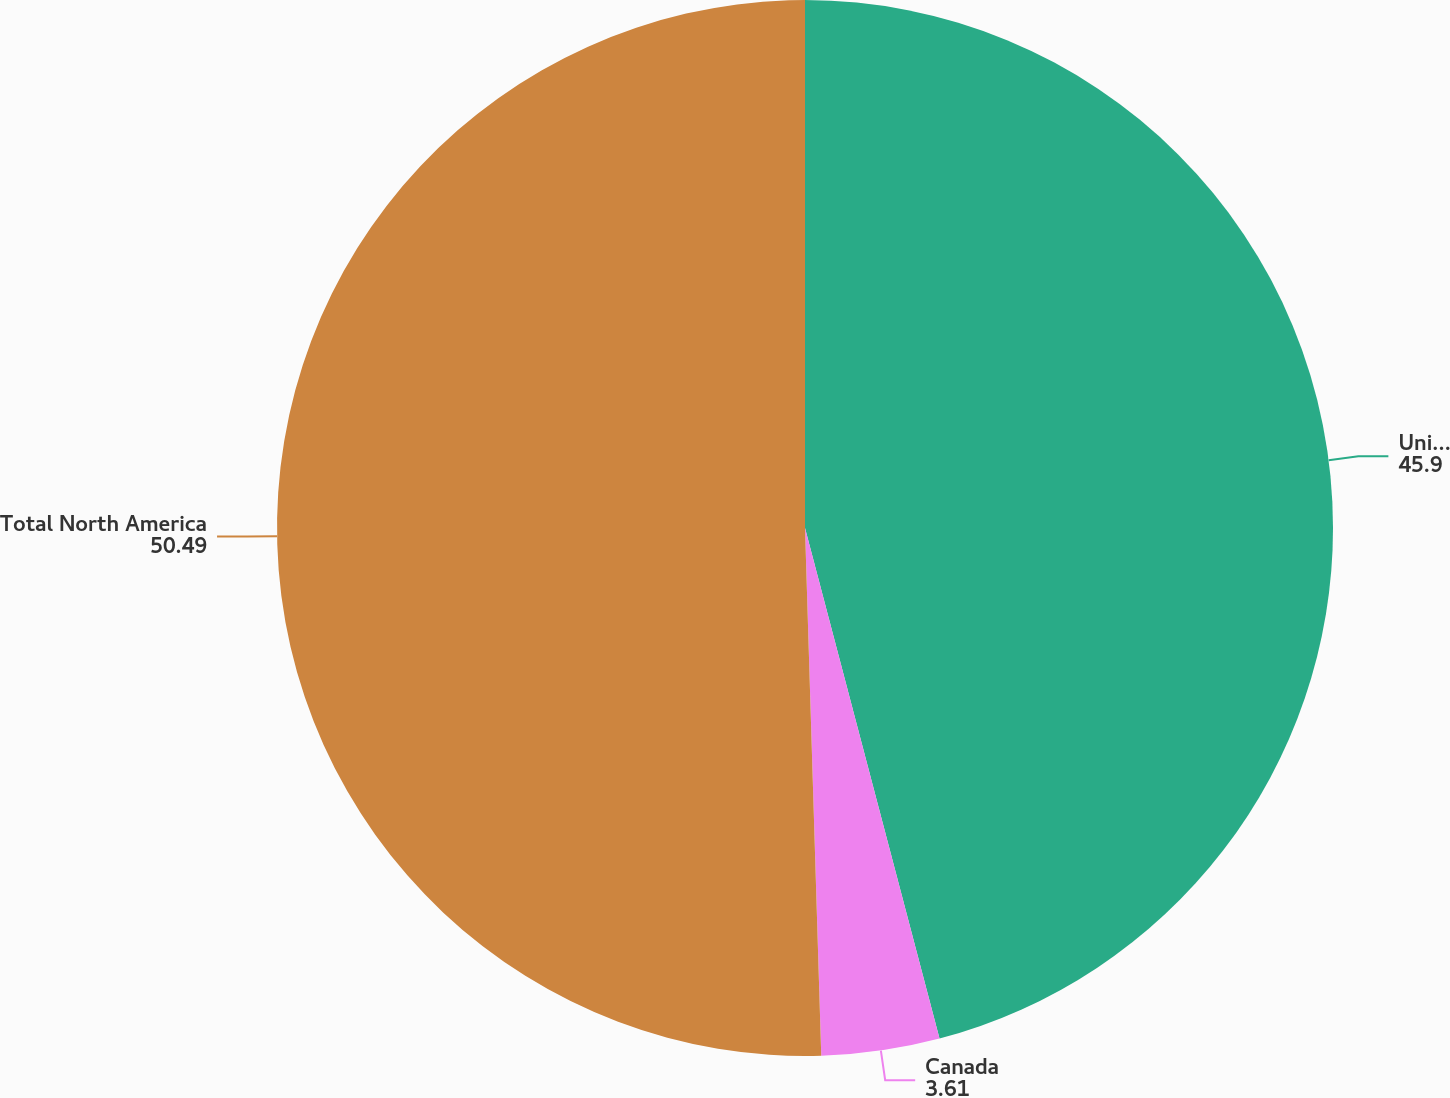<chart> <loc_0><loc_0><loc_500><loc_500><pie_chart><fcel>United States<fcel>Canada<fcel>Total North America<nl><fcel>45.9%<fcel>3.61%<fcel>50.49%<nl></chart> 